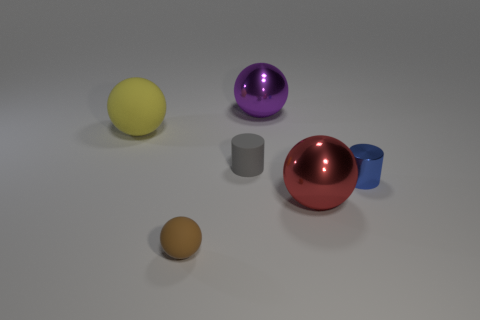There is a ball that is in front of the gray cylinder and to the right of the small matte cylinder; what is its material?
Give a very brief answer. Metal. There is a small thing right of the purple metal object; is its color the same as the rubber cylinder?
Offer a terse response. No. Is the color of the small rubber cylinder the same as the big sphere on the left side of the gray matte cylinder?
Make the answer very short. No. Are there any brown rubber things right of the large red ball?
Offer a terse response. No. Are the big red sphere and the blue cylinder made of the same material?
Your answer should be very brief. Yes. There is a cylinder that is the same size as the gray rubber object; what is its material?
Offer a terse response. Metal. What number of objects are balls that are on the right side of the large yellow matte thing or big purple shiny things?
Your response must be concise. 3. Are there an equal number of gray objects that are behind the big purple object and green rubber cylinders?
Provide a succinct answer. Yes. Is the color of the small rubber sphere the same as the big rubber thing?
Ensure brevity in your answer.  No. What color is the sphere that is behind the blue metal object and in front of the big purple metallic ball?
Make the answer very short. Yellow. 